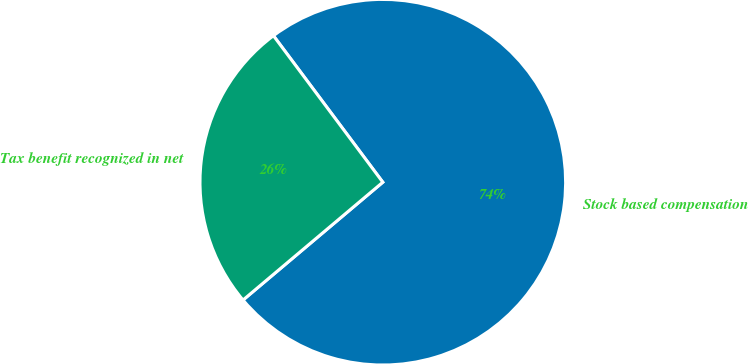<chart> <loc_0><loc_0><loc_500><loc_500><pie_chart><fcel>Stock based compensation<fcel>Tax benefit recognized in net<nl><fcel>74.06%<fcel>25.94%<nl></chart> 